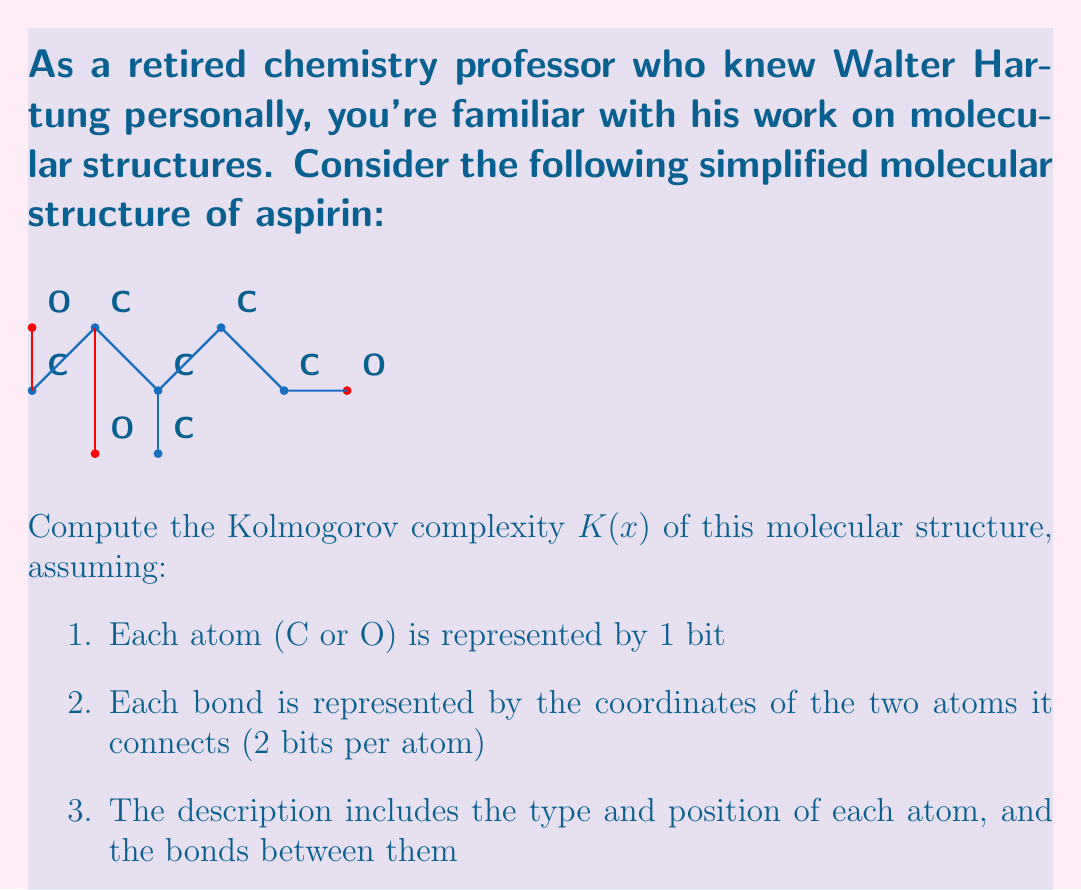Give your solution to this math problem. To compute the Kolmogorov complexity $K(x)$ of this molecular structure, we need to determine the shortest possible description of the structure. Let's break it down step-by-step:

1. Atom representation:
   - There are 6 carbon (C) atoms and 3 oxygen (O) atoms
   - Total bits for atoms: $9 \times 1 = 9$ bits

2. Atom positions:
   - Each atom's position can be described by its coordinates (x,y)
   - Assuming we use 4 bits for each coordinate (2 for x, 2 for y)
   - Total bits for positions: $9 \times 4 = 36$ bits

3. Bond representation:
   - There are 8 bonds in total
   - Each bond is represented by the coordinates of two atoms
   - Total bits for bonds: $8 \times (2 \times 2) = 32$ bits

4. Combining the information:
   - Atom types: 9 bits
   - Atom positions: 36 bits
   - Bonds: 32 bits

The total number of bits required to describe this structure is:

$$K(x) = 9 + 36 + 32 = 77 \text{ bits}$$

This represents the Kolmogorov complexity of the given molecular structure under the specified assumptions.
Answer: $K(x) = 77$ bits 